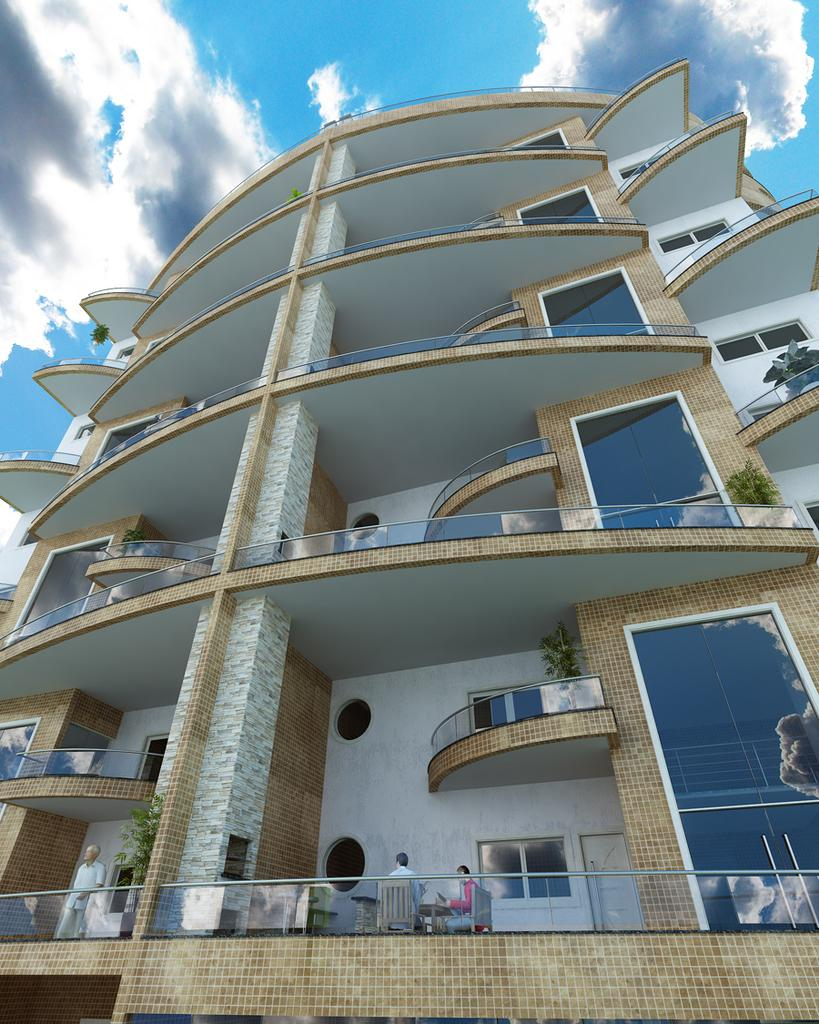What is the main subject in the center of the image? There is a building in the center of the image. What can be seen at the top of the image? The sky is visible at the top of the image. What is present in the sky? Clouds are present in the sky. What type of rail can be seen connecting the building to the wall in the image? There is no rail or wall present in the image; it only features a building and clouds in the sky. 